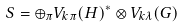Convert formula to latex. <formula><loc_0><loc_0><loc_500><loc_500>S = \oplus _ { \pi } V _ { k \pi } ( H ) ^ { * } \otimes V _ { k \lambda } ( G )</formula> 